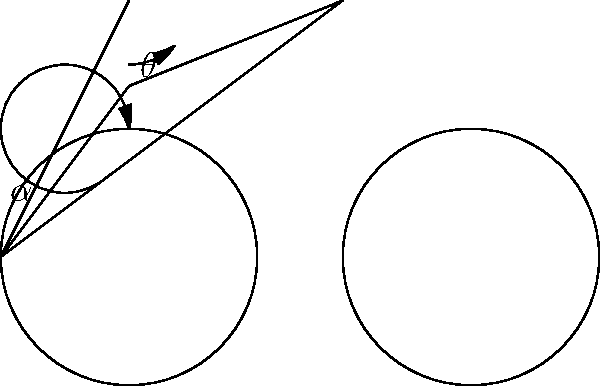In cycling biomechanics, how does adjusting the seat height to change the hip angle ($\theta$) and knee angle ($\alpha$) affect power output? Consider the trade-off between force production and pedaling efficiency. To understand the impact of joint angles on power output in cycling, let's break down the biomechanics:

1. Hip angle ($\theta$):
   - A larger hip angle (more open) allows for greater hip extension.
   - This can increase the power contribution from the gluteal muscles.
   - However, an excessively large angle may reduce pedaling efficiency.

2. Knee angle ($\alpha$):
   - The knee angle at the bottom of the pedal stroke is crucial.
   - An optimal knee angle is typically between 25-35 degrees of flexion.
   - This range balances force production and injury prevention.

3. Power output relationship:
   - Power = Force × Velocity
   - Joint angles affect both force production and pedaling velocity.

4. Force production:
   - Muscles generate maximum force at their optimal length.
   - The hip and knee angles influence the length-tension relationship of the muscles involved.

5. Pedaling efficiency:
   - Efficient pedaling requires smooth force application throughout the pedal stroke.
   - Extreme joint angles can lead to "dead spots" where force application is minimal.

6. Trade-off:
   - A lower seat height (smaller $\theta$, larger $\alpha$) may increase force production but reduce pedaling efficiency.
   - A higher seat height (larger $\theta$, smaller $\alpha$) may improve efficiency but potentially reduce peak force.

7. Optimal setup:
   - The goal is to find a balance that maximizes power output over time.
   - This typically involves a seat height that allows for near full leg extension while maintaining an efficient pedaling motion.

8. Individual factors:
   - Optimal angles can vary based on individual physiology, flexibility, and riding style.
   - Professional bike fits often involve small adjustments to find the ideal position for each rider.

In conclusion, the optimal joint angles for maximum power output strike a balance between force production and pedaling efficiency, typically achieved with a knee angle of 25-35 degrees at the bottom of the pedal stroke and a hip angle that allows for effective gluteal engagement without compromising overall pedaling smoothness.
Answer: Optimal power output is achieved by balancing hip and knee angles to maximize force production and pedaling efficiency, typically with a knee angle of 25-35 degrees at the bottom of the pedal stroke. 